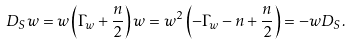Convert formula to latex. <formula><loc_0><loc_0><loc_500><loc_500>D _ { S } w = w \left ( \Gamma _ { w } + \frac { n } { 2 } \right ) w = w ^ { 2 } \left ( - \Gamma _ { w } - n + \frac { n } { 2 } \right ) = - w D _ { S } .</formula> 